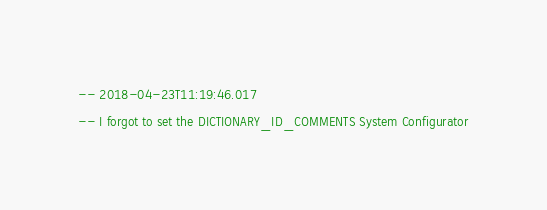Convert code to text. <code><loc_0><loc_0><loc_500><loc_500><_SQL_>-- 2018-04-23T11:19:46.017
-- I forgot to set the DICTIONARY_ID_COMMENTS System Configurator</code> 